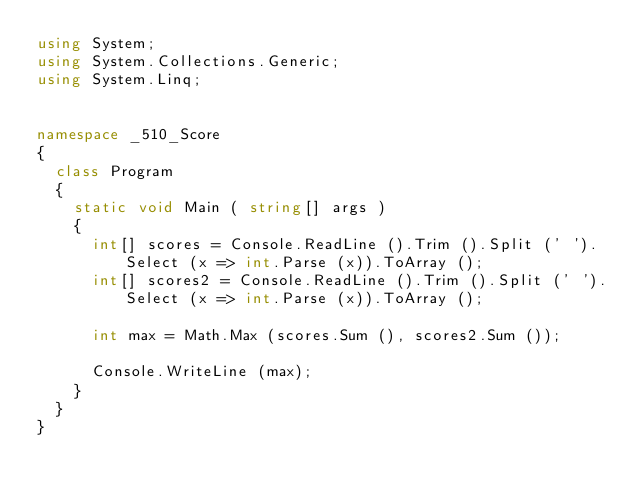Convert code to text. <code><loc_0><loc_0><loc_500><loc_500><_C#_>using System;
using System.Collections.Generic;
using System.Linq;


namespace _510_Score
{
	class Program
	{
		static void Main ( string[] args )
		{
			int[] scores = Console.ReadLine ().Trim ().Split (' ').Select (x => int.Parse (x)).ToArray ();
			int[] scores2 = Console.ReadLine ().Trim ().Split (' ').Select (x => int.Parse (x)).ToArray ();

			int max = Math.Max (scores.Sum (), scores2.Sum ());

			Console.WriteLine (max);
		}
	}
}</code> 